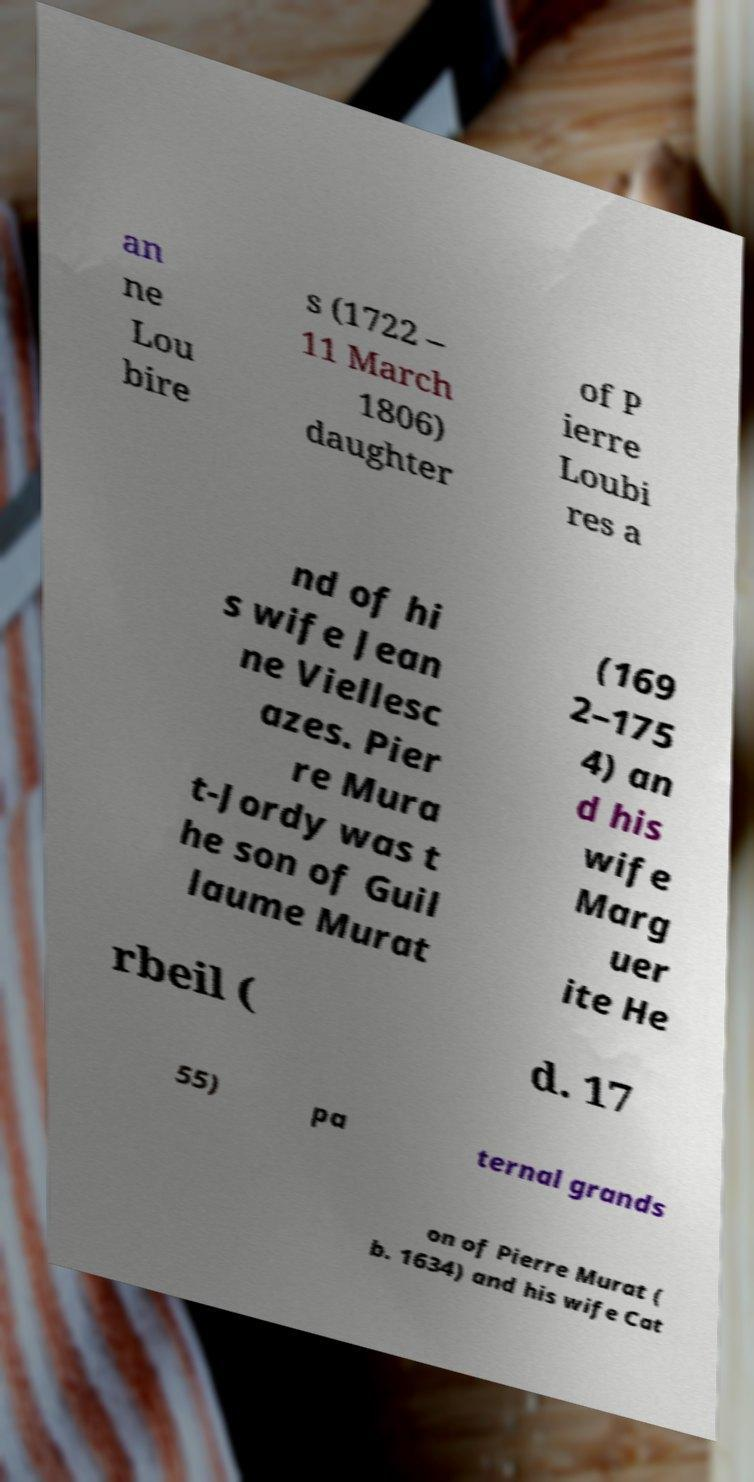Could you extract and type out the text from this image? an ne Lou bire s (1722 – 11 March 1806) daughter of P ierre Loubi res a nd of hi s wife Jean ne Viellesc azes. Pier re Mura t-Jordy was t he son of Guil laume Murat (169 2–175 4) an d his wife Marg uer ite He rbeil ( d. 17 55) pa ternal grands on of Pierre Murat ( b. 1634) and his wife Cat 